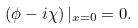<formula> <loc_0><loc_0><loc_500><loc_500>\left ( \phi - i \chi \right ) | _ { x = 0 } = 0 .</formula> 